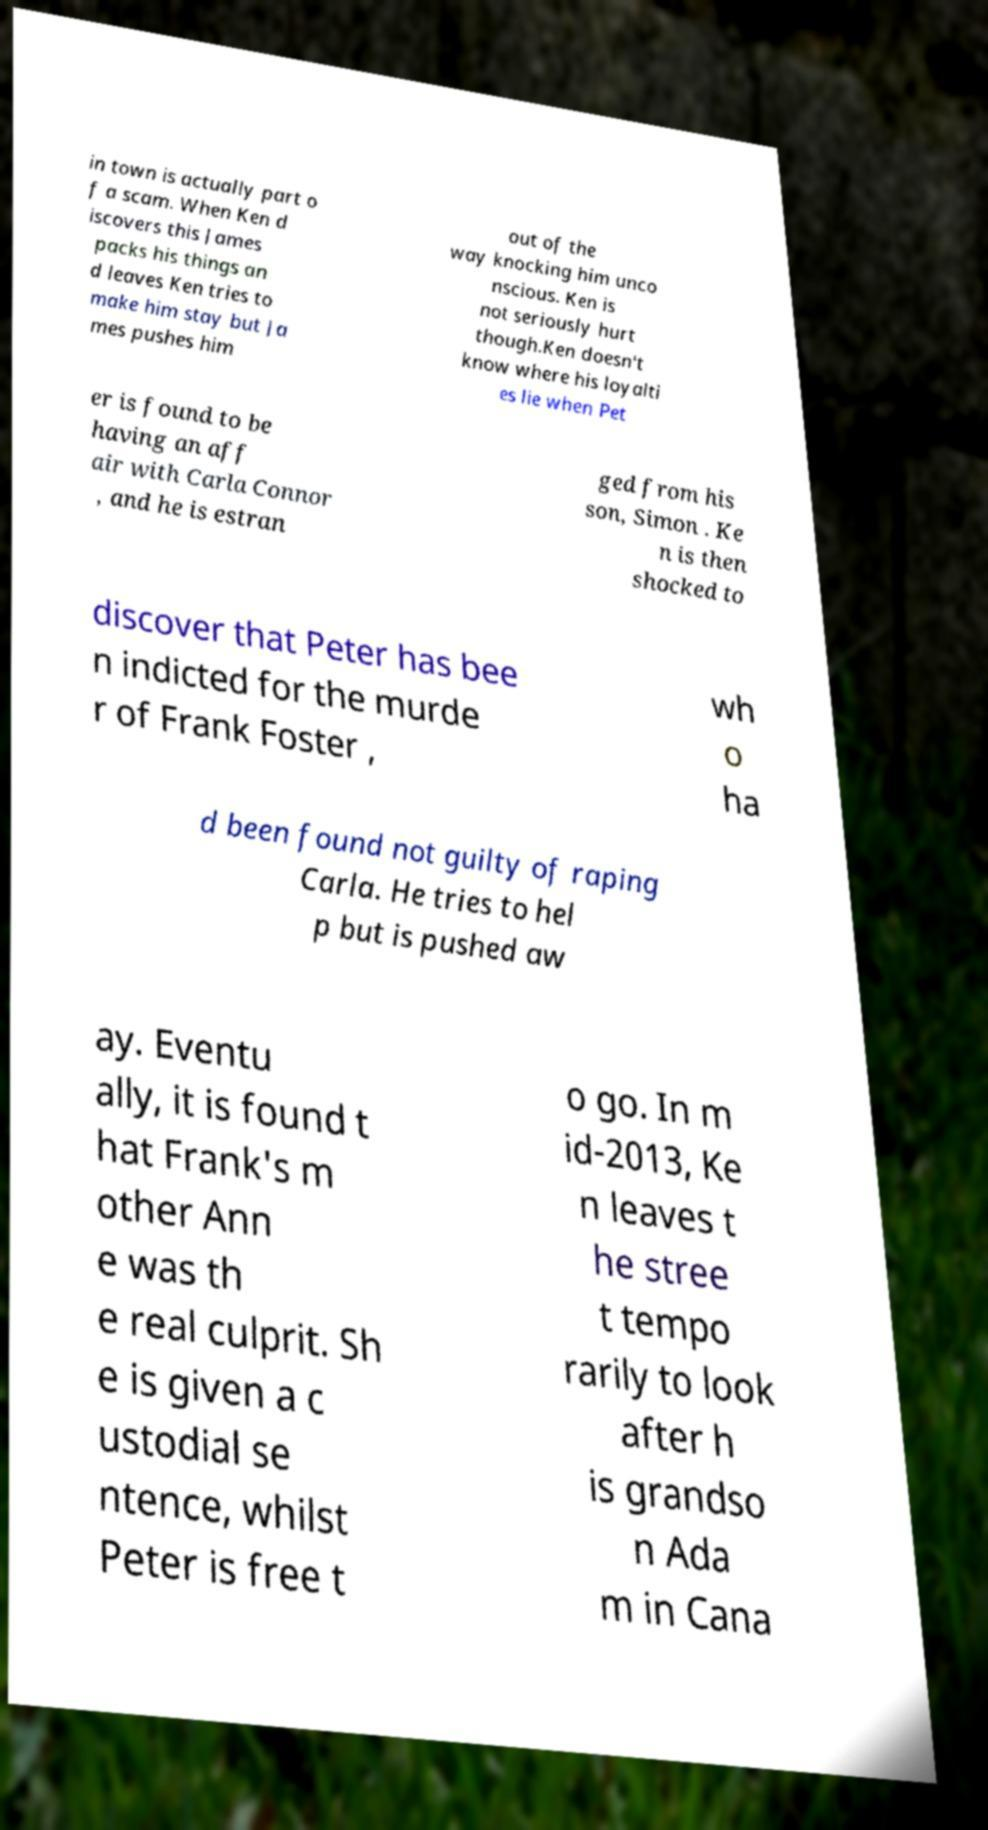I need the written content from this picture converted into text. Can you do that? in town is actually part o f a scam. When Ken d iscovers this James packs his things an d leaves Ken tries to make him stay but Ja mes pushes him out of the way knocking him unco nscious. Ken is not seriously hurt though.Ken doesn't know where his loyalti es lie when Pet er is found to be having an aff air with Carla Connor , and he is estran ged from his son, Simon . Ke n is then shocked to discover that Peter has bee n indicted for the murde r of Frank Foster , wh o ha d been found not guilty of raping Carla. He tries to hel p but is pushed aw ay. Eventu ally, it is found t hat Frank's m other Ann e was th e real culprit. Sh e is given a c ustodial se ntence, whilst Peter is free t o go. In m id-2013, Ke n leaves t he stree t tempo rarily to look after h is grandso n Ada m in Cana 